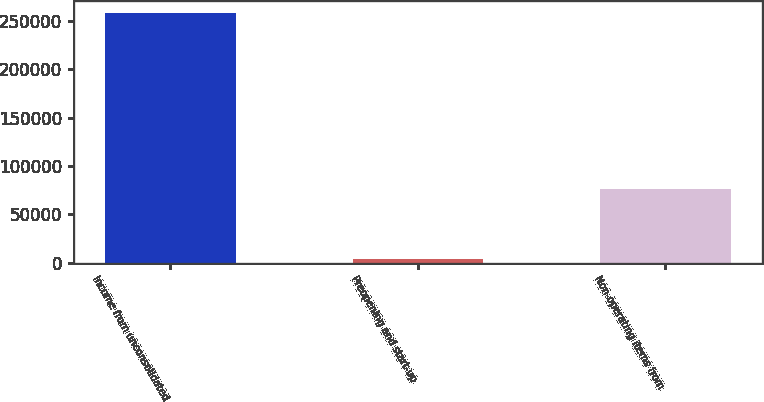Convert chart to OTSL. <chart><loc_0><loc_0><loc_500><loc_500><bar_chart><fcel>Income from unconsolidated<fcel>Preopening and start-up<fcel>Non-operating items from<nl><fcel>257883<fcel>3475<fcel>76462<nl></chart> 